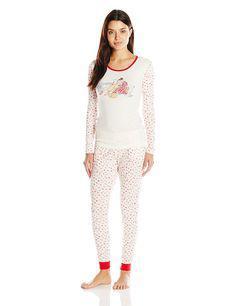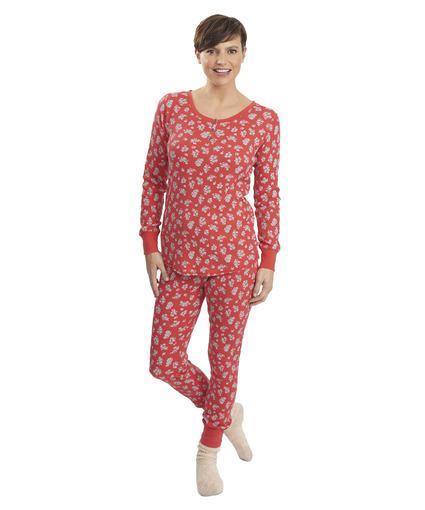The first image is the image on the left, the second image is the image on the right. Given the left and right images, does the statement "One pair of pajamas has red trim around the neck and the ankles." hold true? Answer yes or no. Yes. The first image is the image on the left, the second image is the image on the right. For the images displayed, is the sentence "All of the girls are brunettes." factually correct? Answer yes or no. Yes. 